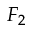<formula> <loc_0><loc_0><loc_500><loc_500>F _ { 2 }</formula> 